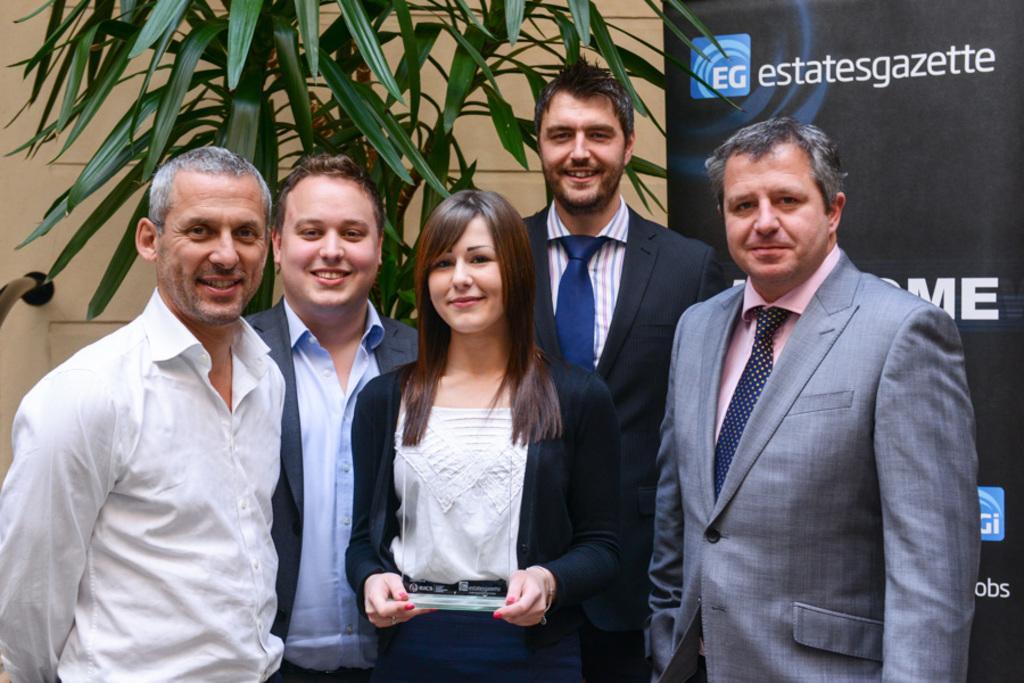Describe this image in one or two sentences. In the foreground of the picture there are group of people standing, they are having smiley faces. On the right there is a banner. On the left there is a hand railing. In the center of the background there is a tree. 